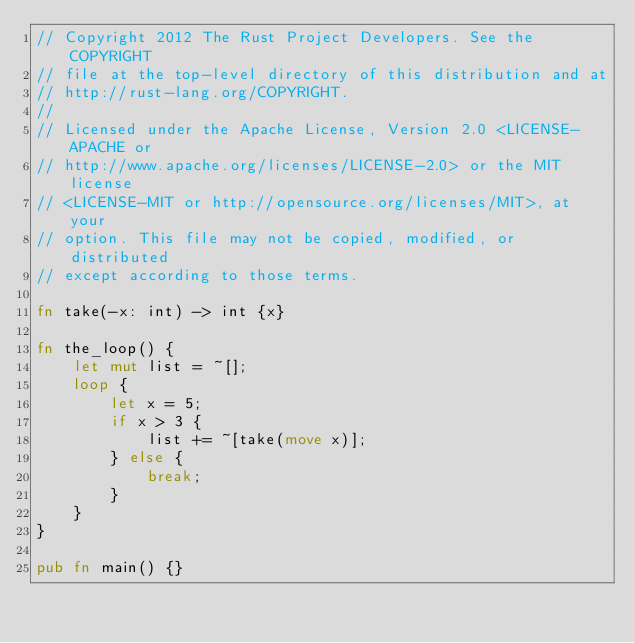Convert code to text. <code><loc_0><loc_0><loc_500><loc_500><_Rust_>// Copyright 2012 The Rust Project Developers. See the COPYRIGHT
// file at the top-level directory of this distribution and at
// http://rust-lang.org/COPYRIGHT.
//
// Licensed under the Apache License, Version 2.0 <LICENSE-APACHE or
// http://www.apache.org/licenses/LICENSE-2.0> or the MIT license
// <LICENSE-MIT or http://opensource.org/licenses/MIT>, at your
// option. This file may not be copied, modified, or distributed
// except according to those terms.

fn take(-x: int) -> int {x}

fn the_loop() {
    let mut list = ~[];
    loop {
        let x = 5;
        if x > 3 {
            list += ~[take(move x)];
        } else {
            break;
        }
    }
}

pub fn main() {}
</code> 